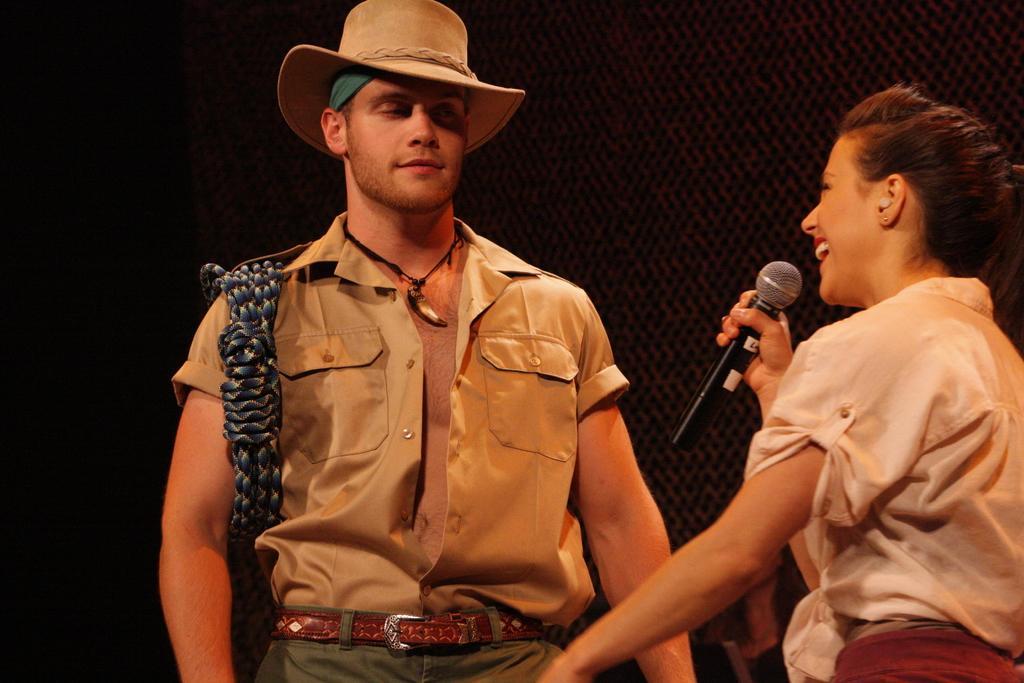In one or two sentences, can you explain what this image depicts? To the right side of the image there is a lady holding a mic. Beside her there is a person wearing a hat. 